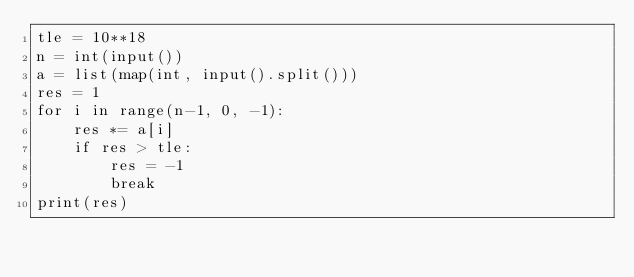Convert code to text. <code><loc_0><loc_0><loc_500><loc_500><_Python_>tle = 10**18
n = int(input())
a = list(map(int, input().split()))
res = 1
for i in range(n-1, 0, -1):
    res *= a[i]
    if res > tle:
        res = -1
        break    
print(res)
</code> 